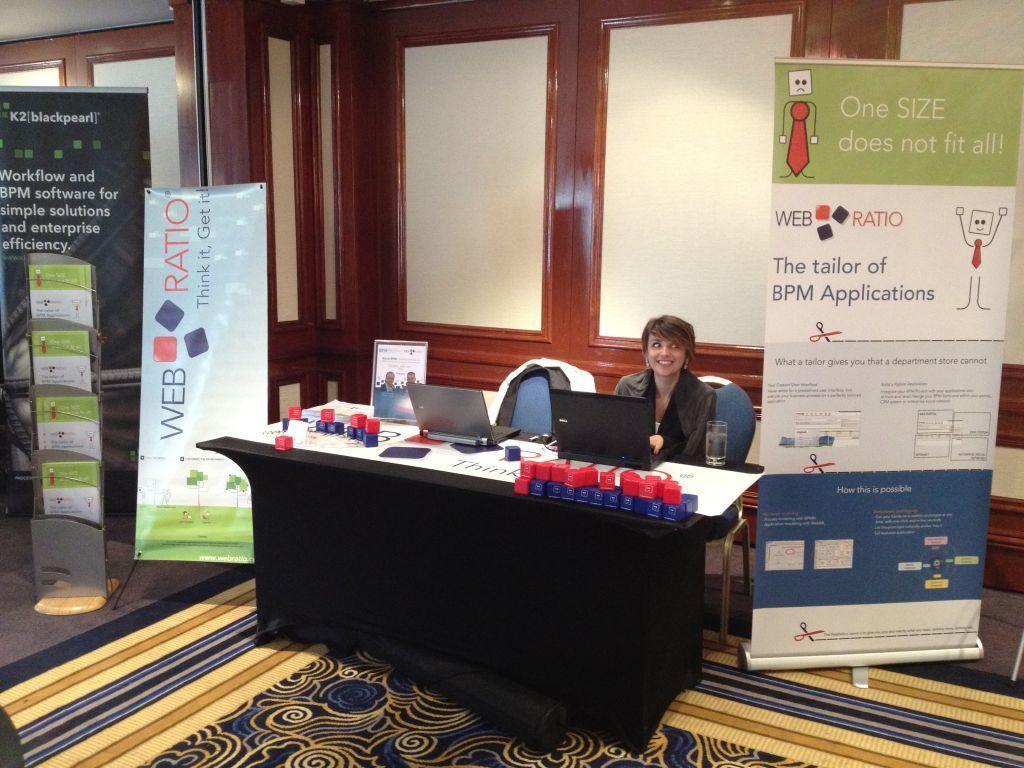Could you give a brief overview of what you see in this image? In this picture we can see woman sitting on chair and smiling and in front of her there is table and on table we have two laptops, photo frame and in background we can see wall, banners. 